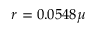Convert formula to latex. <formula><loc_0><loc_0><loc_500><loc_500>r = 0 . 0 5 4 8 \mu</formula> 